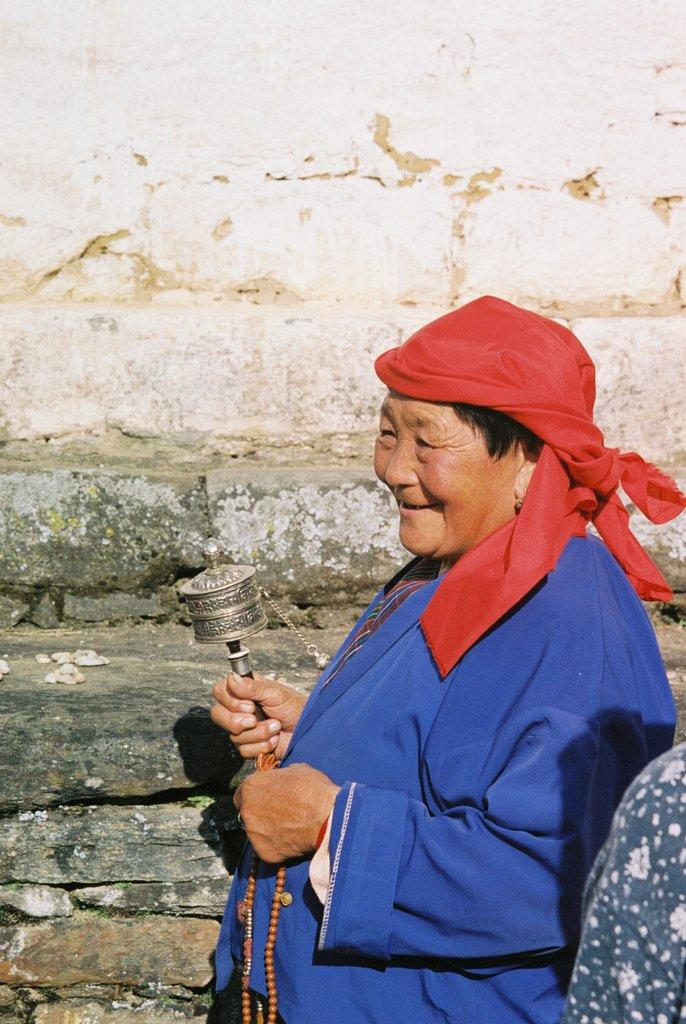Who is the main subject in the image? There is a woman in the center of the image. What can be seen in the background of the image? There is a wall in the background of the image. What type of land is visible in the image? There is no specific type of land visible in the image; it only features a woman and a wall in the background. What hobbies does the woman have, as depicted in the image? The image does not provide any information about the woman's hobbies. 